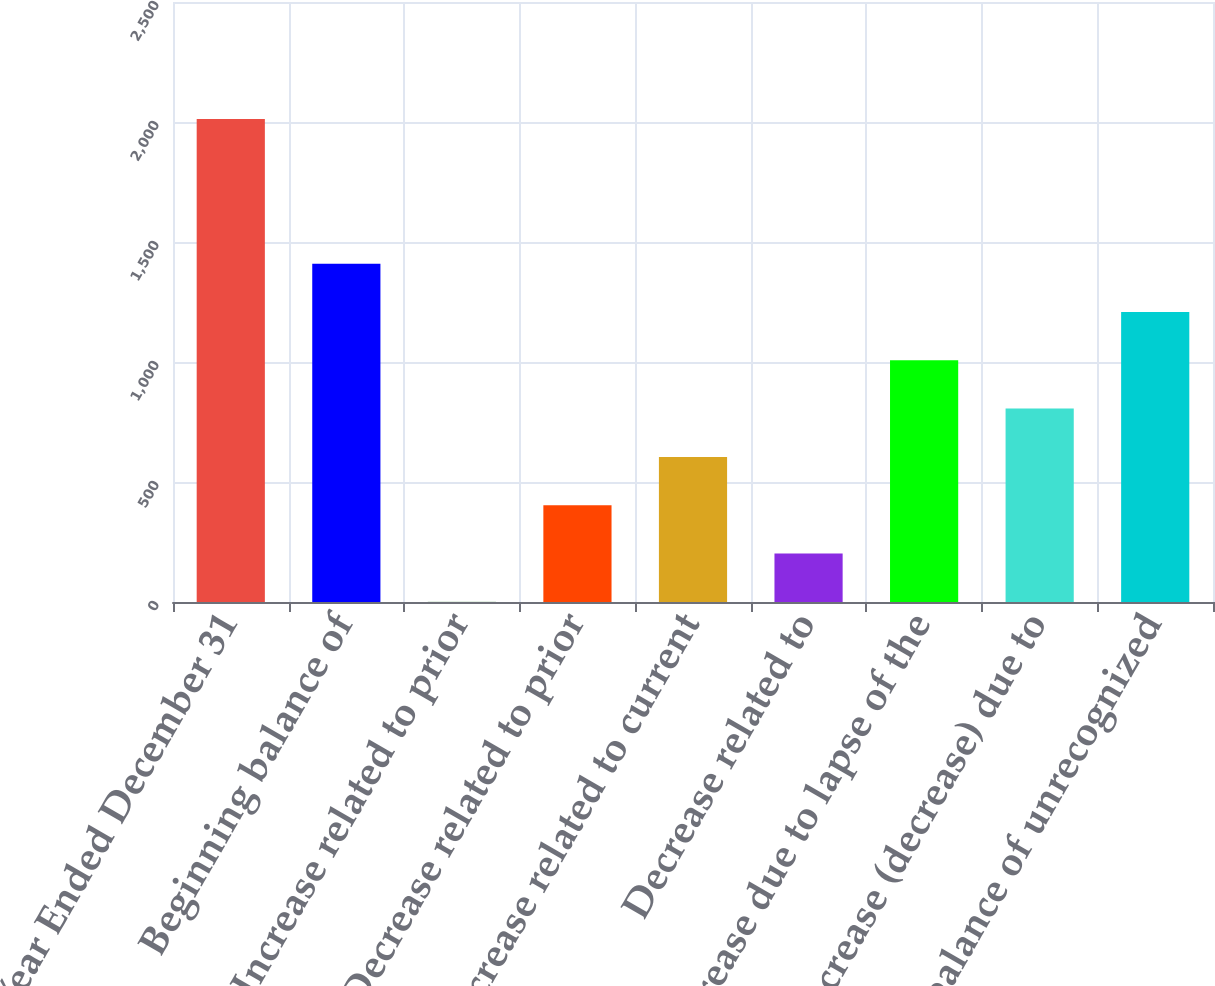Convert chart. <chart><loc_0><loc_0><loc_500><loc_500><bar_chart><fcel>Year Ended December 31<fcel>Beginning balance of<fcel>Increase related to prior<fcel>Decrease related to prior<fcel>Increase related to current<fcel>Decrease related to<fcel>Decrease due to lapse of the<fcel>Increase (decrease) due to<fcel>Ending balance of unrecognized<nl><fcel>2013<fcel>1409.4<fcel>1<fcel>403.4<fcel>604.6<fcel>202.2<fcel>1007<fcel>805.8<fcel>1208.2<nl></chart> 